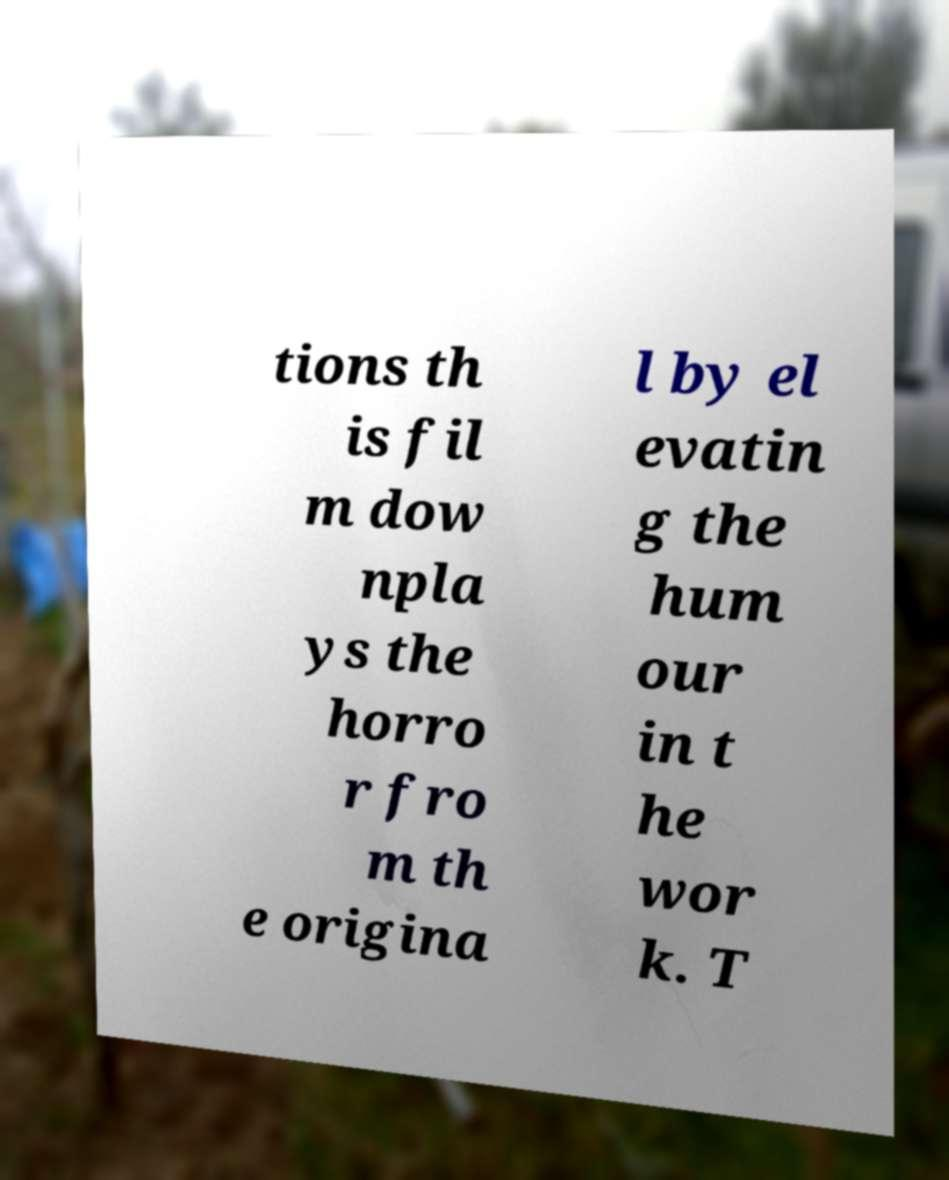What messages or text are displayed in this image? I need them in a readable, typed format. tions th is fil m dow npla ys the horro r fro m th e origina l by el evatin g the hum our in t he wor k. T 